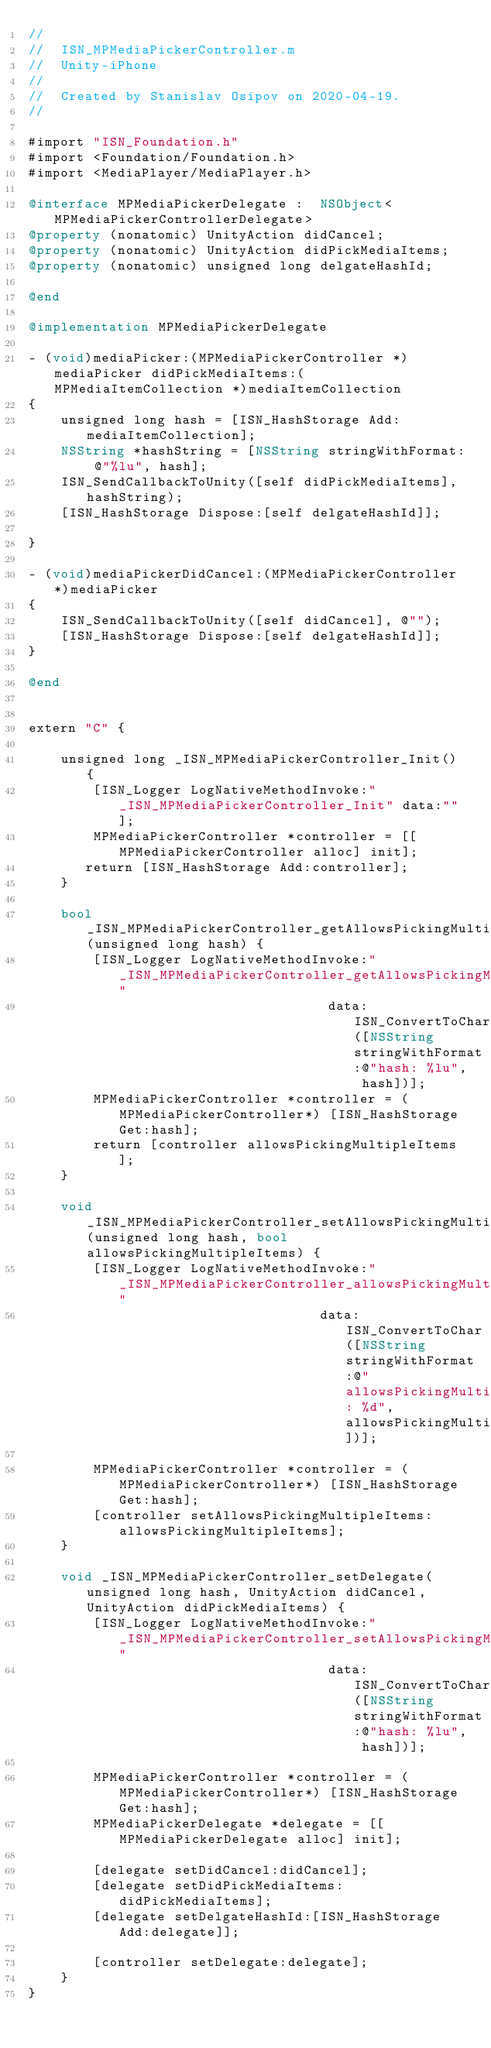Convert code to text. <code><loc_0><loc_0><loc_500><loc_500><_ObjectiveC_>//
//  ISN_MPMediaPickerController.m
//  Unity-iPhone
//
//  Created by Stanislav Osipov on 2020-04-19.
//

#import "ISN_Foundation.h"
#import <Foundation/Foundation.h>
#import <MediaPlayer/MediaPlayer.h>

@interface MPMediaPickerDelegate :  NSObject<MPMediaPickerControllerDelegate>
@property (nonatomic) UnityAction didCancel;
@property (nonatomic) UnityAction didPickMediaItems;
@property (nonatomic) unsigned long delgateHashId;

@end

@implementation MPMediaPickerDelegate

- (void)mediaPicker:(MPMediaPickerController *)mediaPicker didPickMediaItems:(MPMediaItemCollection *)mediaItemCollection
{
    unsigned long hash = [ISN_HashStorage Add:mediaItemCollection];
    NSString *hashString = [NSString stringWithFormat: @"%lu", hash];
    ISN_SendCallbackToUnity([self didPickMediaItems], hashString);
    [ISN_HashStorage Dispose:[self delgateHashId]];
   
}

- (void)mediaPickerDidCancel:(MPMediaPickerController *)mediaPicker
{
    ISN_SendCallbackToUnity([self didCancel], @"");
    [ISN_HashStorage Dispose:[self delgateHashId]];
}

@end


extern "C" {

    unsigned long _ISN_MPMediaPickerController_Init() {
        [ISN_Logger LogNativeMethodInvoke:"_ISN_MPMediaPickerController_Init" data:""];
        MPMediaPickerController *controller = [[MPMediaPickerController alloc] init];
       return [ISN_HashStorage Add:controller];
    }

    bool _ISN_MPMediaPickerController_getAllowsPickingMultipleItems(unsigned long hash) {
        [ISN_Logger LogNativeMethodInvoke:"_ISN_MPMediaPickerController_getAllowsPickingMultipleItems"
                                     data: ISN_ConvertToChar([NSString stringWithFormat:@"hash: %lu", hash])];
        MPMediaPickerController *controller = (MPMediaPickerController*) [ISN_HashStorage Get:hash];
        return [controller allowsPickingMultipleItems];
    }
    
    void _ISN_MPMediaPickerController_setAllowsPickingMultipleItems(unsigned long hash, bool allowsPickingMultipleItems) {
        [ISN_Logger LogNativeMethodInvoke:"_ISN_MPMediaPickerController_allowsPickingMultipleItems"
                                    data: ISN_ConvertToChar([NSString stringWithFormat:@"allowsPickingMultipleItems: %d", allowsPickingMultipleItems])];

        MPMediaPickerController *controller = (MPMediaPickerController*) [ISN_HashStorage Get:hash];
        [controller setAllowsPickingMultipleItems:allowsPickingMultipleItems];
    }

    void _ISN_MPMediaPickerController_setDelegate(unsigned long hash, UnityAction didCancel, UnityAction didPickMediaItems) {
        [ISN_Logger LogNativeMethodInvoke:"_ISN_MPMediaPickerController_setAllowsPickingMultipleItems"
                                     data: ISN_ConvertToChar([NSString stringWithFormat:@"hash: %lu", hash])];

        MPMediaPickerController *controller = (MPMediaPickerController*) [ISN_HashStorage Get:hash];
        MPMediaPickerDelegate *delegate = [[MPMediaPickerDelegate alloc] init];
        
        [delegate setDidCancel:didCancel];
        [delegate setDidPickMediaItems:didPickMediaItems];
        [delegate setDelgateHashId:[ISN_HashStorage Add:delegate]];
        
        [controller setDelegate:delegate];
    }
}
</code> 